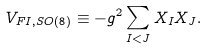Convert formula to latex. <formula><loc_0><loc_0><loc_500><loc_500>V _ { F I , S O \left ( 8 \right ) } \equiv - g ^ { 2 } \sum _ { I < J } X _ { I } X _ { J } .</formula> 